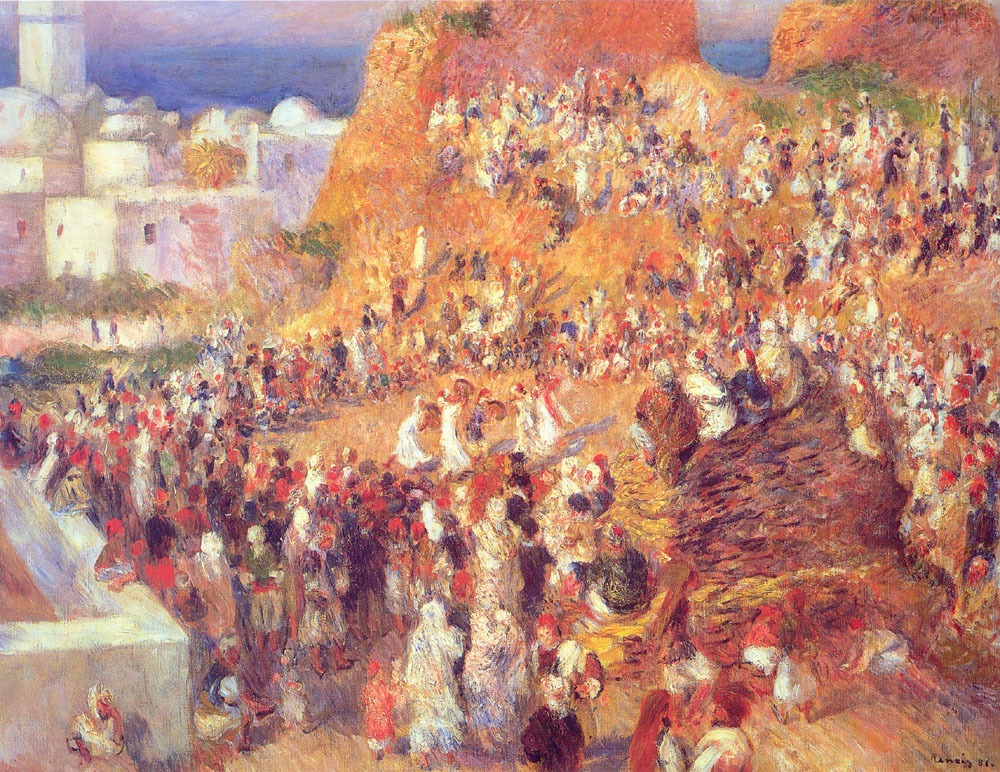Describe the mood of the crowd and the time of day this scene might represent. The mood amongst the crowd in the painting feels animated and vivacious, with people engaged in dynamic interactions that suggest a sense of community and liveliness. The warm color tones, with deep shadows and the golden glow cast upon the buildings and the crowd, indicate that the time of day may be in the late afternoon, leading towards the golden hour prior to the evening. Such a time is often when markets are bustling with patrons securing provisions for their evening meals and enjoying the cooler temperatures after a hot day. 